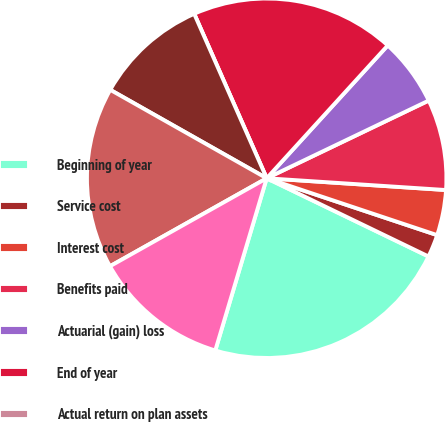Convert chart to OTSL. <chart><loc_0><loc_0><loc_500><loc_500><pie_chart><fcel>Beginning of year<fcel>Service cost<fcel>Interest cost<fcel>Benefits paid<fcel>Actuarial (gain) loss<fcel>End of year<fcel>Actual return on plan assets<fcel>Employer contributions<fcel>Funded status and accrued<fcel>Current liabilities<nl><fcel>22.45%<fcel>2.04%<fcel>4.08%<fcel>8.16%<fcel>6.12%<fcel>18.37%<fcel>0.0%<fcel>10.2%<fcel>16.33%<fcel>12.24%<nl></chart> 